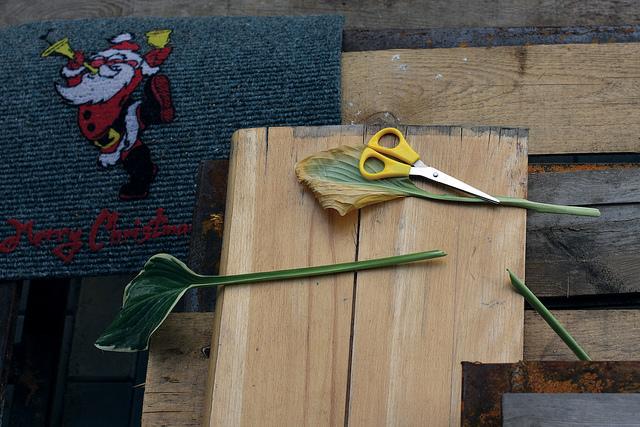Who is pictured in the top left?
Short answer required. Santa. What is being cut?
Write a very short answer. Stem. What color are the scissors?
Answer briefly. Yellow. 